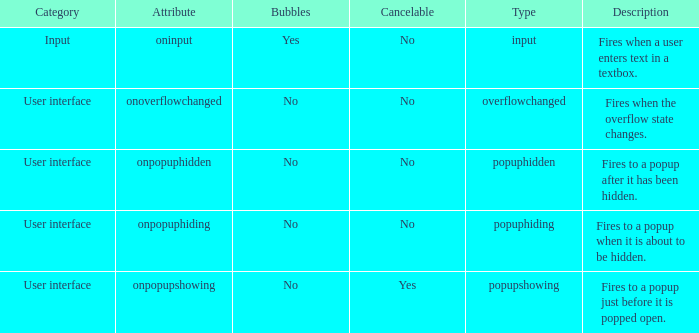What's the bubbles with attribute being onpopuphidden No. Could you parse the entire table? {'header': ['Category', 'Attribute', 'Bubbles', 'Cancelable', 'Type', 'Description'], 'rows': [['Input', 'oninput', 'Yes', 'No', 'input', 'Fires when a user enters text in a textbox.'], ['User interface', 'onoverflowchanged', 'No', 'No', 'overflowchanged', 'Fires when the overflow state changes.'], ['User interface', 'onpopuphidden', 'No', 'No', 'popuphidden', 'Fires to a popup after it has been hidden.'], ['User interface', 'onpopuphiding', 'No', 'No', 'popuphiding', 'Fires to a popup when it is about to be hidden.'], ['User interface', 'onpopupshowing', 'No', 'Yes', 'popupshowing', 'Fires to a popup just before it is popped open.']]} 